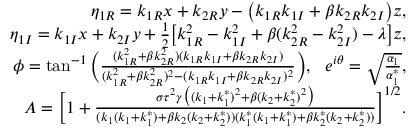<formula> <loc_0><loc_0><loc_500><loc_500>\begin{array} { r l r } & { \eta _ { 1 R } = k _ { 1 R } x + k _ { 2 R } y - \left ( k _ { 1 R } k _ { 1 I } + \beta k _ { 2 R } k _ { 2 I } \right ) z , } \\ & { \eta _ { 1 I } = k _ { 1 I } x + k _ { 2 I } y + \frac { 1 } { 2 } \left [ k _ { 1 R } ^ { 2 } - k _ { 1 I } ^ { 2 } + \beta ( k _ { 2 R } ^ { 2 } - k _ { 2 I } ^ { 2 } ) - \lambda \right ] z , } \\ & { \phi = \tan ^ { - 1 } \left ( \frac { ( k _ { 1 R } ^ { 2 } + \beta k _ { 2 R } ^ { 2 } ) ( k _ { 1 R } k _ { 1 I } + \beta k _ { 2 R } k _ { 2 I } ) } { ( k _ { 1 R } ^ { 2 } + \beta k _ { 2 R } ^ { 2 } ) ^ { 2 } - ( k _ { 1 R } k _ { 1 I } + \beta k _ { 2 R } k _ { 2 I } ) ^ { 2 } } \right ) , e ^ { i \theta } = \sqrt { \frac { \alpha _ { 1 } } { \alpha _ { 1 } ^ { * } } } , } \\ & { A = \left [ 1 + \frac { \sigma \tau ^ { 2 } \gamma \left ( ( k _ { 1 } + k _ { 1 } ^ { * } ) ^ { 2 } + \beta ( k _ { 2 } + k _ { 2 } ^ { * } ) ^ { 2 } \right ) } { ( k _ { 1 } ( k _ { 1 } + k _ { 1 } ^ { * } ) + \beta k _ { 2 } ( k _ { 2 } + k _ { 2 } ^ { * } ) ) ( k _ { 1 } ^ { * } ( k _ { 1 } + k _ { 1 } ^ { * } ) + \beta k _ { 2 } ^ { * } ( k _ { 2 } + k _ { 2 } ^ { * } ) ) } \right ] ^ { 1 / 2 } . } \end{array}</formula> 